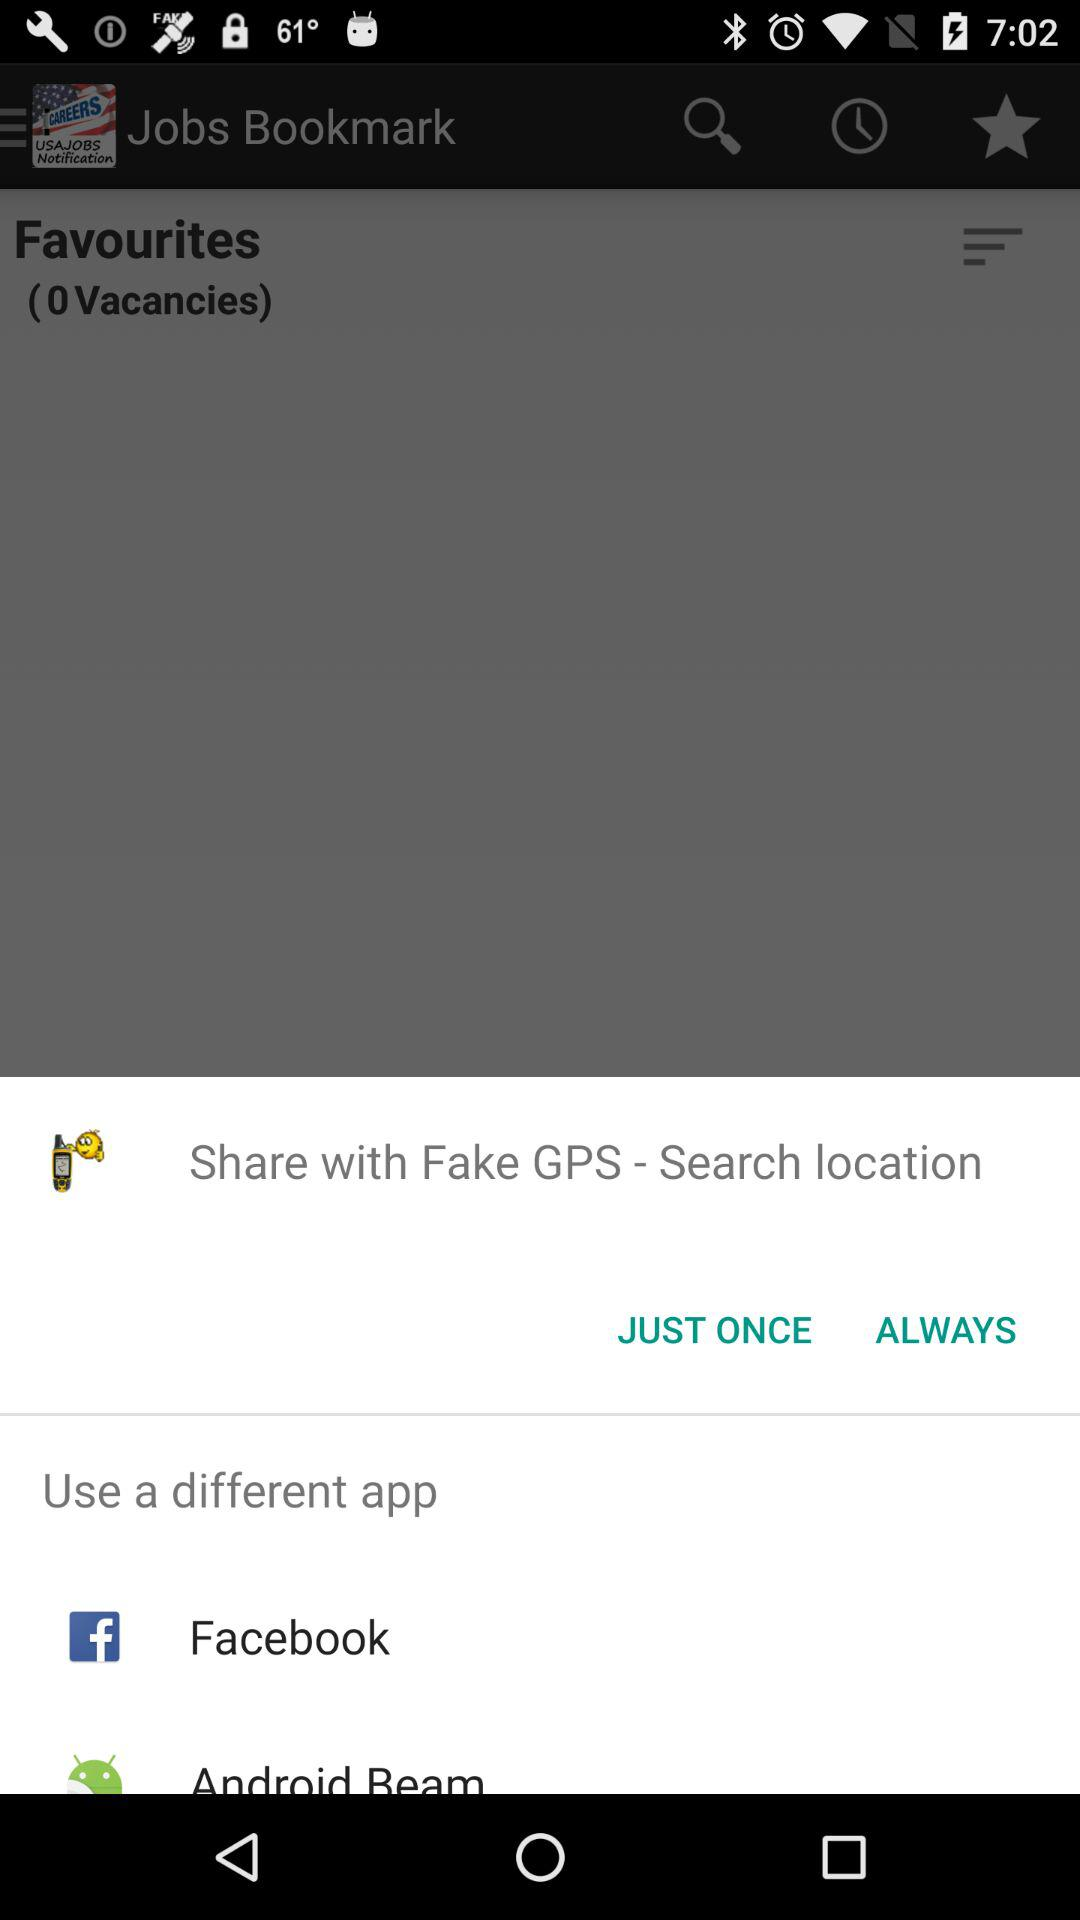When was the last job bookmarked?
When the provided information is insufficient, respond with <no answer>. <no answer> 